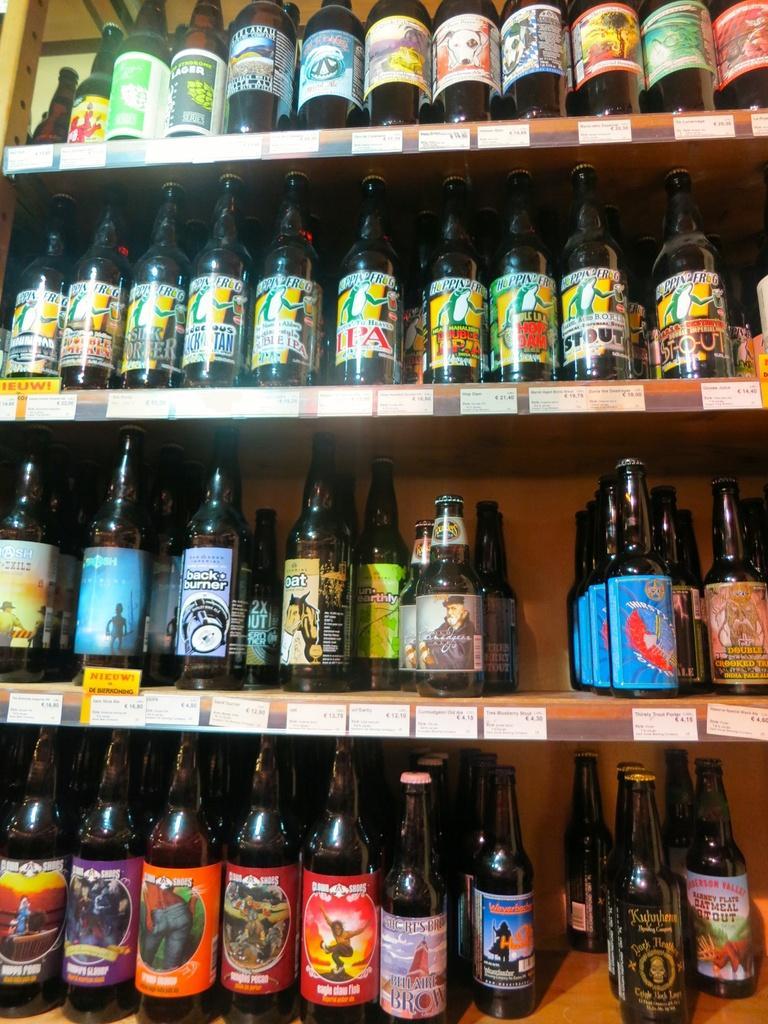How would you summarize this image in a sentence or two? In this image i can see few bottles in a rack. 